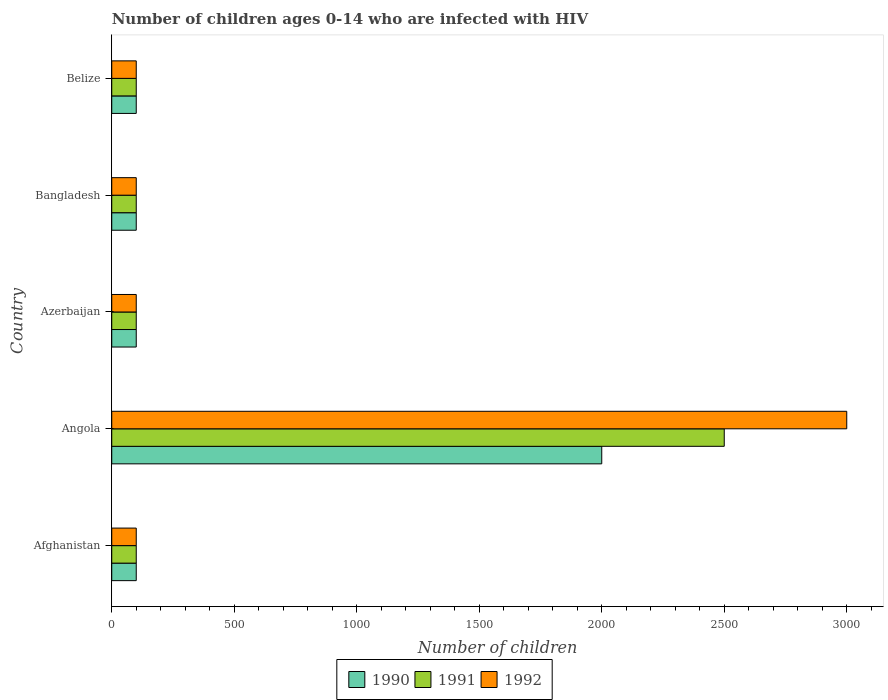How many groups of bars are there?
Provide a succinct answer. 5. How many bars are there on the 5th tick from the top?
Ensure brevity in your answer.  3. What is the label of the 2nd group of bars from the top?
Provide a succinct answer. Bangladesh. What is the number of HIV infected children in 1990 in Afghanistan?
Your answer should be very brief. 100. Across all countries, what is the maximum number of HIV infected children in 1992?
Ensure brevity in your answer.  3000. Across all countries, what is the minimum number of HIV infected children in 1991?
Ensure brevity in your answer.  100. In which country was the number of HIV infected children in 1992 maximum?
Offer a terse response. Angola. In which country was the number of HIV infected children in 1991 minimum?
Your response must be concise. Afghanistan. What is the total number of HIV infected children in 1991 in the graph?
Your answer should be very brief. 2900. What is the difference between the number of HIV infected children in 1992 in Angola and that in Belize?
Provide a succinct answer. 2900. What is the average number of HIV infected children in 1990 per country?
Keep it short and to the point. 480. In how many countries, is the number of HIV infected children in 1990 greater than 1300 ?
Ensure brevity in your answer.  1. What is the ratio of the number of HIV infected children in 1990 in Angola to that in Azerbaijan?
Make the answer very short. 20. Is the difference between the number of HIV infected children in 1992 in Azerbaijan and Belize greater than the difference between the number of HIV infected children in 1990 in Azerbaijan and Belize?
Provide a succinct answer. No. What is the difference between the highest and the second highest number of HIV infected children in 1992?
Your answer should be very brief. 2900. What is the difference between the highest and the lowest number of HIV infected children in 1992?
Keep it short and to the point. 2900. In how many countries, is the number of HIV infected children in 1992 greater than the average number of HIV infected children in 1992 taken over all countries?
Make the answer very short. 1. What does the 2nd bar from the top in Azerbaijan represents?
Provide a succinct answer. 1991. Are all the bars in the graph horizontal?
Your response must be concise. Yes. How many countries are there in the graph?
Keep it short and to the point. 5. What is the difference between two consecutive major ticks on the X-axis?
Ensure brevity in your answer.  500. Are the values on the major ticks of X-axis written in scientific E-notation?
Provide a succinct answer. No. Does the graph contain any zero values?
Keep it short and to the point. No. Does the graph contain grids?
Your answer should be compact. No. How many legend labels are there?
Give a very brief answer. 3. How are the legend labels stacked?
Give a very brief answer. Horizontal. What is the title of the graph?
Keep it short and to the point. Number of children ages 0-14 who are infected with HIV. What is the label or title of the X-axis?
Offer a very short reply. Number of children. What is the label or title of the Y-axis?
Offer a very short reply. Country. What is the Number of children of 1991 in Angola?
Offer a very short reply. 2500. What is the Number of children of 1992 in Angola?
Provide a short and direct response. 3000. What is the Number of children of 1992 in Azerbaijan?
Make the answer very short. 100. What is the Number of children of 1992 in Bangladesh?
Ensure brevity in your answer.  100. What is the Number of children of 1990 in Belize?
Make the answer very short. 100. What is the Number of children of 1992 in Belize?
Make the answer very short. 100. Across all countries, what is the maximum Number of children in 1991?
Provide a succinct answer. 2500. Across all countries, what is the maximum Number of children in 1992?
Your answer should be compact. 3000. Across all countries, what is the minimum Number of children of 1991?
Provide a short and direct response. 100. Across all countries, what is the minimum Number of children of 1992?
Provide a short and direct response. 100. What is the total Number of children of 1990 in the graph?
Ensure brevity in your answer.  2400. What is the total Number of children in 1991 in the graph?
Your answer should be very brief. 2900. What is the total Number of children of 1992 in the graph?
Offer a terse response. 3400. What is the difference between the Number of children of 1990 in Afghanistan and that in Angola?
Ensure brevity in your answer.  -1900. What is the difference between the Number of children of 1991 in Afghanistan and that in Angola?
Your answer should be very brief. -2400. What is the difference between the Number of children of 1992 in Afghanistan and that in Angola?
Ensure brevity in your answer.  -2900. What is the difference between the Number of children of 1990 in Afghanistan and that in Azerbaijan?
Your answer should be compact. 0. What is the difference between the Number of children in 1991 in Afghanistan and that in Azerbaijan?
Ensure brevity in your answer.  0. What is the difference between the Number of children of 1992 in Afghanistan and that in Azerbaijan?
Your answer should be compact. 0. What is the difference between the Number of children in 1991 in Afghanistan and that in Bangladesh?
Your response must be concise. 0. What is the difference between the Number of children of 1992 in Afghanistan and that in Bangladesh?
Offer a very short reply. 0. What is the difference between the Number of children in 1991 in Afghanistan and that in Belize?
Offer a terse response. 0. What is the difference between the Number of children in 1990 in Angola and that in Azerbaijan?
Offer a very short reply. 1900. What is the difference between the Number of children in 1991 in Angola and that in Azerbaijan?
Give a very brief answer. 2400. What is the difference between the Number of children of 1992 in Angola and that in Azerbaijan?
Offer a terse response. 2900. What is the difference between the Number of children in 1990 in Angola and that in Bangladesh?
Provide a short and direct response. 1900. What is the difference between the Number of children in 1991 in Angola and that in Bangladesh?
Your response must be concise. 2400. What is the difference between the Number of children of 1992 in Angola and that in Bangladesh?
Provide a short and direct response. 2900. What is the difference between the Number of children of 1990 in Angola and that in Belize?
Ensure brevity in your answer.  1900. What is the difference between the Number of children of 1991 in Angola and that in Belize?
Keep it short and to the point. 2400. What is the difference between the Number of children of 1992 in Angola and that in Belize?
Provide a succinct answer. 2900. What is the difference between the Number of children in 1990 in Azerbaijan and that in Bangladesh?
Offer a very short reply. 0. What is the difference between the Number of children of 1991 in Azerbaijan and that in Bangladesh?
Offer a very short reply. 0. What is the difference between the Number of children in 1992 in Azerbaijan and that in Bangladesh?
Offer a very short reply. 0. What is the difference between the Number of children in 1990 in Azerbaijan and that in Belize?
Your answer should be very brief. 0. What is the difference between the Number of children in 1990 in Bangladesh and that in Belize?
Provide a short and direct response. 0. What is the difference between the Number of children in 1991 in Bangladesh and that in Belize?
Provide a succinct answer. 0. What is the difference between the Number of children of 1990 in Afghanistan and the Number of children of 1991 in Angola?
Offer a very short reply. -2400. What is the difference between the Number of children in 1990 in Afghanistan and the Number of children in 1992 in Angola?
Ensure brevity in your answer.  -2900. What is the difference between the Number of children in 1991 in Afghanistan and the Number of children in 1992 in Angola?
Your answer should be very brief. -2900. What is the difference between the Number of children in 1990 in Afghanistan and the Number of children in 1991 in Bangladesh?
Ensure brevity in your answer.  0. What is the difference between the Number of children in 1991 in Afghanistan and the Number of children in 1992 in Bangladesh?
Make the answer very short. 0. What is the difference between the Number of children of 1990 in Afghanistan and the Number of children of 1991 in Belize?
Offer a terse response. 0. What is the difference between the Number of children of 1991 in Afghanistan and the Number of children of 1992 in Belize?
Your answer should be very brief. 0. What is the difference between the Number of children in 1990 in Angola and the Number of children in 1991 in Azerbaijan?
Provide a succinct answer. 1900. What is the difference between the Number of children of 1990 in Angola and the Number of children of 1992 in Azerbaijan?
Keep it short and to the point. 1900. What is the difference between the Number of children in 1991 in Angola and the Number of children in 1992 in Azerbaijan?
Give a very brief answer. 2400. What is the difference between the Number of children of 1990 in Angola and the Number of children of 1991 in Bangladesh?
Make the answer very short. 1900. What is the difference between the Number of children in 1990 in Angola and the Number of children in 1992 in Bangladesh?
Provide a short and direct response. 1900. What is the difference between the Number of children in 1991 in Angola and the Number of children in 1992 in Bangladesh?
Your response must be concise. 2400. What is the difference between the Number of children of 1990 in Angola and the Number of children of 1991 in Belize?
Keep it short and to the point. 1900. What is the difference between the Number of children in 1990 in Angola and the Number of children in 1992 in Belize?
Your answer should be very brief. 1900. What is the difference between the Number of children in 1991 in Angola and the Number of children in 1992 in Belize?
Offer a terse response. 2400. What is the difference between the Number of children in 1990 in Azerbaijan and the Number of children in 1991 in Belize?
Offer a terse response. 0. What is the difference between the Number of children in 1991 in Azerbaijan and the Number of children in 1992 in Belize?
Your answer should be compact. 0. What is the average Number of children in 1990 per country?
Your answer should be compact. 480. What is the average Number of children in 1991 per country?
Make the answer very short. 580. What is the average Number of children in 1992 per country?
Ensure brevity in your answer.  680. What is the difference between the Number of children of 1990 and Number of children of 1991 in Afghanistan?
Provide a short and direct response. 0. What is the difference between the Number of children in 1990 and Number of children in 1992 in Afghanistan?
Ensure brevity in your answer.  0. What is the difference between the Number of children of 1990 and Number of children of 1991 in Angola?
Your answer should be compact. -500. What is the difference between the Number of children in 1990 and Number of children in 1992 in Angola?
Provide a short and direct response. -1000. What is the difference between the Number of children in 1991 and Number of children in 1992 in Angola?
Give a very brief answer. -500. What is the difference between the Number of children in 1990 and Number of children in 1991 in Azerbaijan?
Give a very brief answer. 0. What is the difference between the Number of children of 1991 and Number of children of 1992 in Azerbaijan?
Provide a succinct answer. 0. What is the difference between the Number of children in 1990 and Number of children in 1992 in Bangladesh?
Give a very brief answer. 0. What is the difference between the Number of children of 1991 and Number of children of 1992 in Bangladesh?
Offer a very short reply. 0. What is the difference between the Number of children in 1990 and Number of children in 1991 in Belize?
Make the answer very short. 0. What is the ratio of the Number of children of 1990 in Afghanistan to that in Angola?
Offer a terse response. 0.05. What is the ratio of the Number of children of 1991 in Afghanistan to that in Angola?
Provide a succinct answer. 0.04. What is the ratio of the Number of children in 1992 in Afghanistan to that in Angola?
Your answer should be compact. 0.03. What is the ratio of the Number of children in 1991 in Afghanistan to that in Azerbaijan?
Provide a short and direct response. 1. What is the ratio of the Number of children in 1992 in Afghanistan to that in Bangladesh?
Ensure brevity in your answer.  1. What is the ratio of the Number of children of 1990 in Afghanistan to that in Belize?
Your answer should be very brief. 1. What is the ratio of the Number of children of 1991 in Afghanistan to that in Belize?
Your answer should be very brief. 1. What is the ratio of the Number of children in 1991 in Angola to that in Azerbaijan?
Make the answer very short. 25. What is the ratio of the Number of children of 1990 in Angola to that in Bangladesh?
Offer a terse response. 20. What is the ratio of the Number of children in 1990 in Angola to that in Belize?
Your response must be concise. 20. What is the ratio of the Number of children of 1991 in Angola to that in Belize?
Give a very brief answer. 25. What is the ratio of the Number of children of 1992 in Angola to that in Belize?
Provide a succinct answer. 30. What is the ratio of the Number of children of 1990 in Azerbaijan to that in Bangladesh?
Your answer should be very brief. 1. What is the ratio of the Number of children of 1991 in Azerbaijan to that in Bangladesh?
Make the answer very short. 1. What is the ratio of the Number of children in 1990 in Azerbaijan to that in Belize?
Your answer should be very brief. 1. What is the ratio of the Number of children in 1991 in Azerbaijan to that in Belize?
Offer a terse response. 1. What is the ratio of the Number of children of 1990 in Bangladesh to that in Belize?
Offer a terse response. 1. What is the difference between the highest and the second highest Number of children in 1990?
Offer a terse response. 1900. What is the difference between the highest and the second highest Number of children in 1991?
Provide a succinct answer. 2400. What is the difference between the highest and the second highest Number of children of 1992?
Offer a terse response. 2900. What is the difference between the highest and the lowest Number of children of 1990?
Provide a succinct answer. 1900. What is the difference between the highest and the lowest Number of children in 1991?
Your response must be concise. 2400. What is the difference between the highest and the lowest Number of children in 1992?
Provide a succinct answer. 2900. 